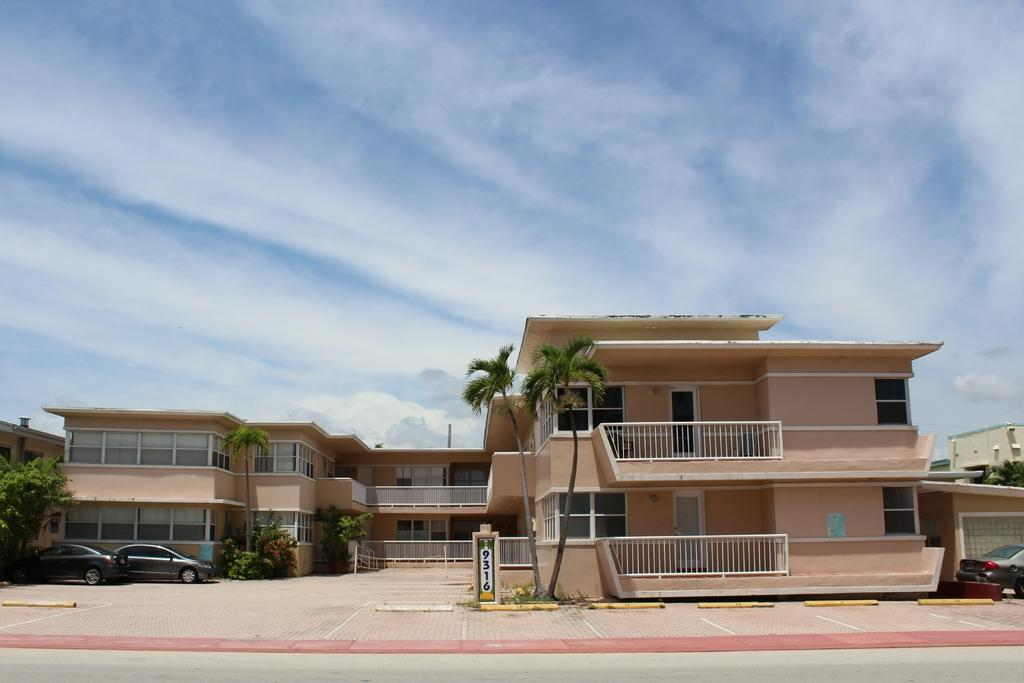What type of structures can be seen in the image? There are buildings in the image. What is located in front of the buildings? Trees are present in front of the buildings. What else can be seen on the ground in front of the buildings? Vehicles are parked on the path in front of the buildings. What is visible behind the buildings? The sky is visible behind the buildings. What type of rock is being used to cause a disturbance in the image? There is no rock or disturbance present in the image. 